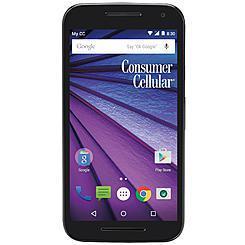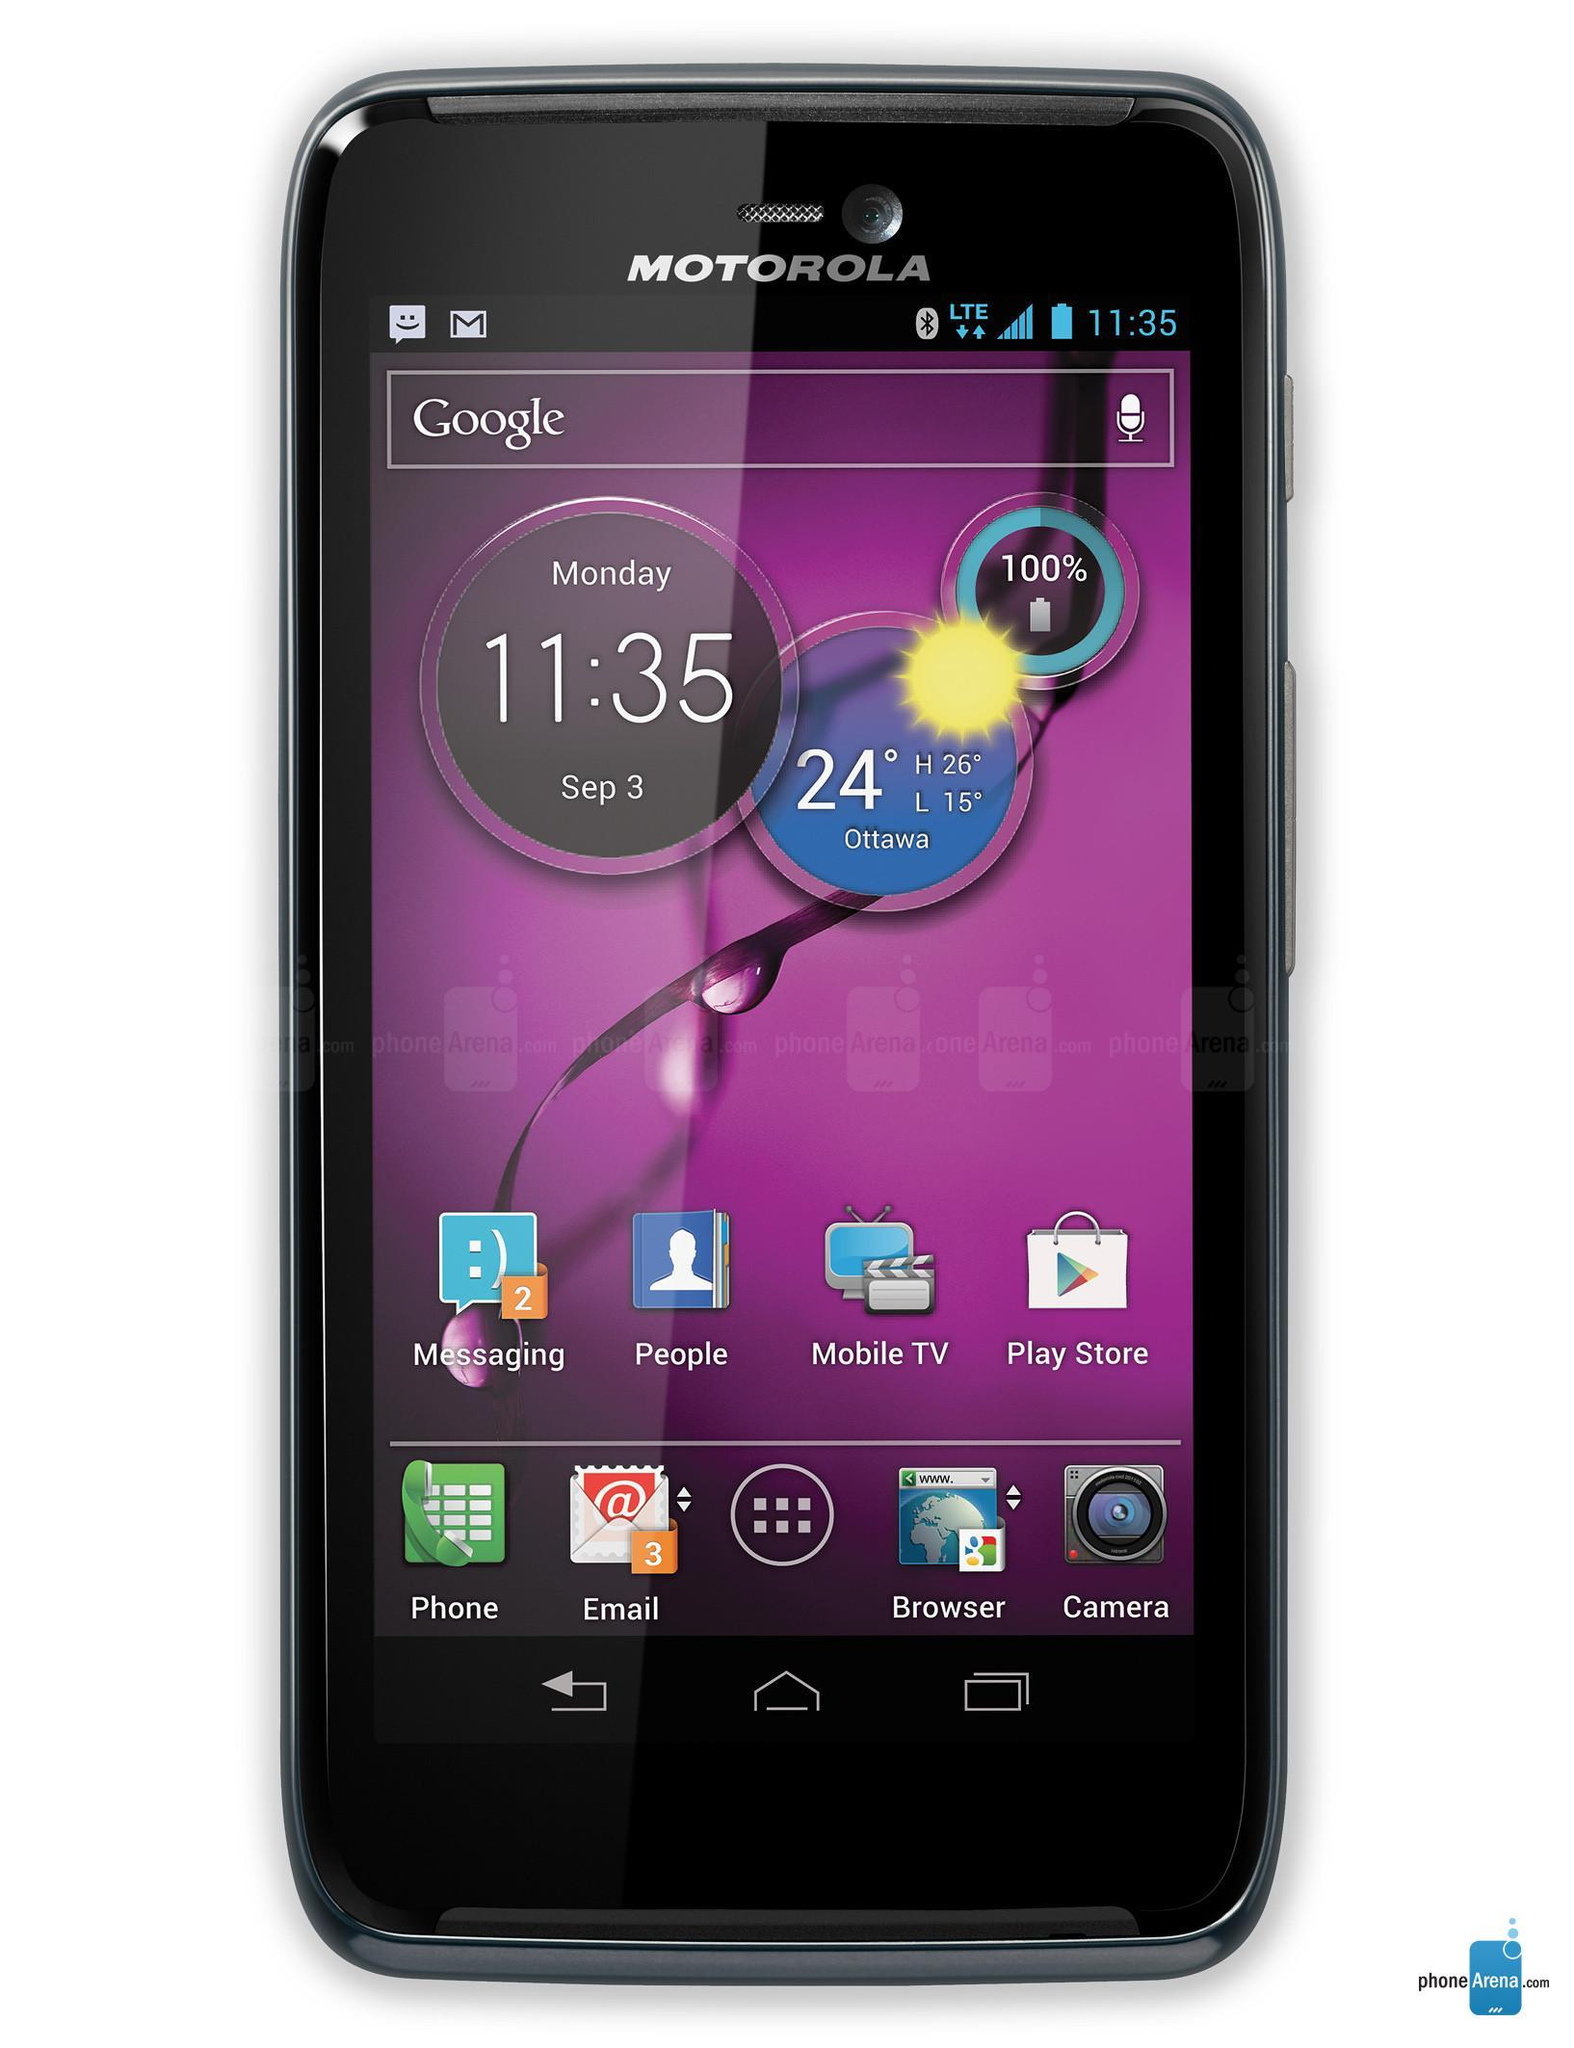The first image is the image on the left, the second image is the image on the right. Given the left and right images, does the statement "Each image shows a rectangular device with flat ends and sides, rounded corners, and 'lit' screen displayed head-on, and at least one of the devices is black." hold true? Answer yes or no. Yes. 